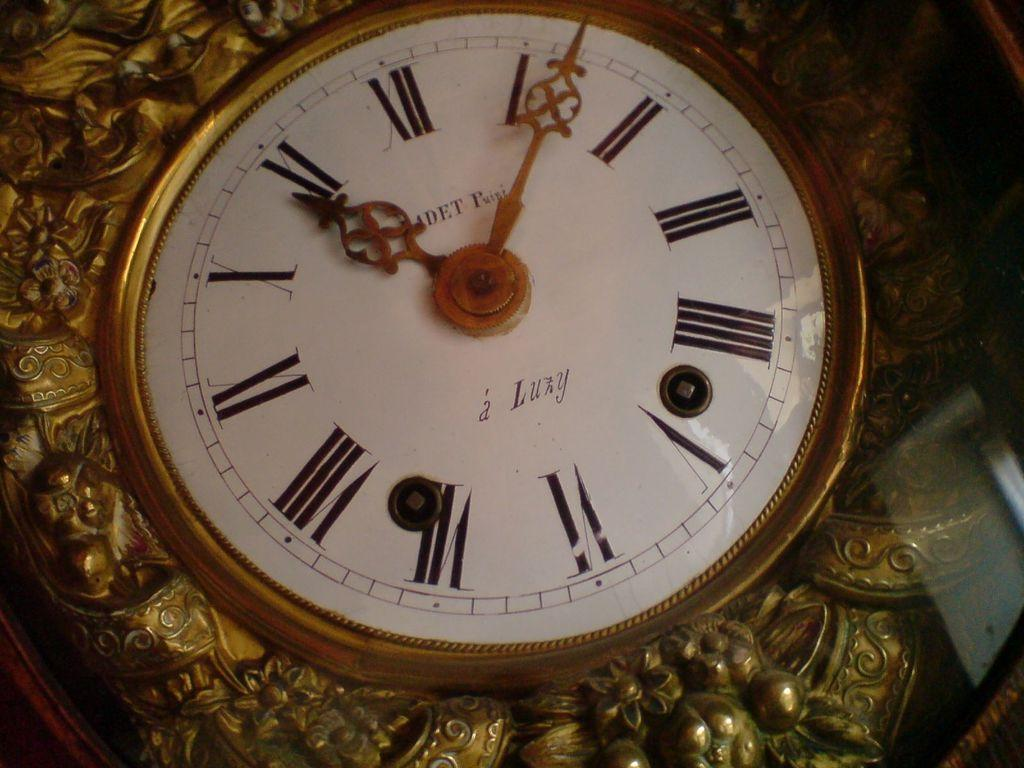<image>
Give a short and clear explanation of the subsequent image. An ornate a Luzy clock with a time of 10:07 